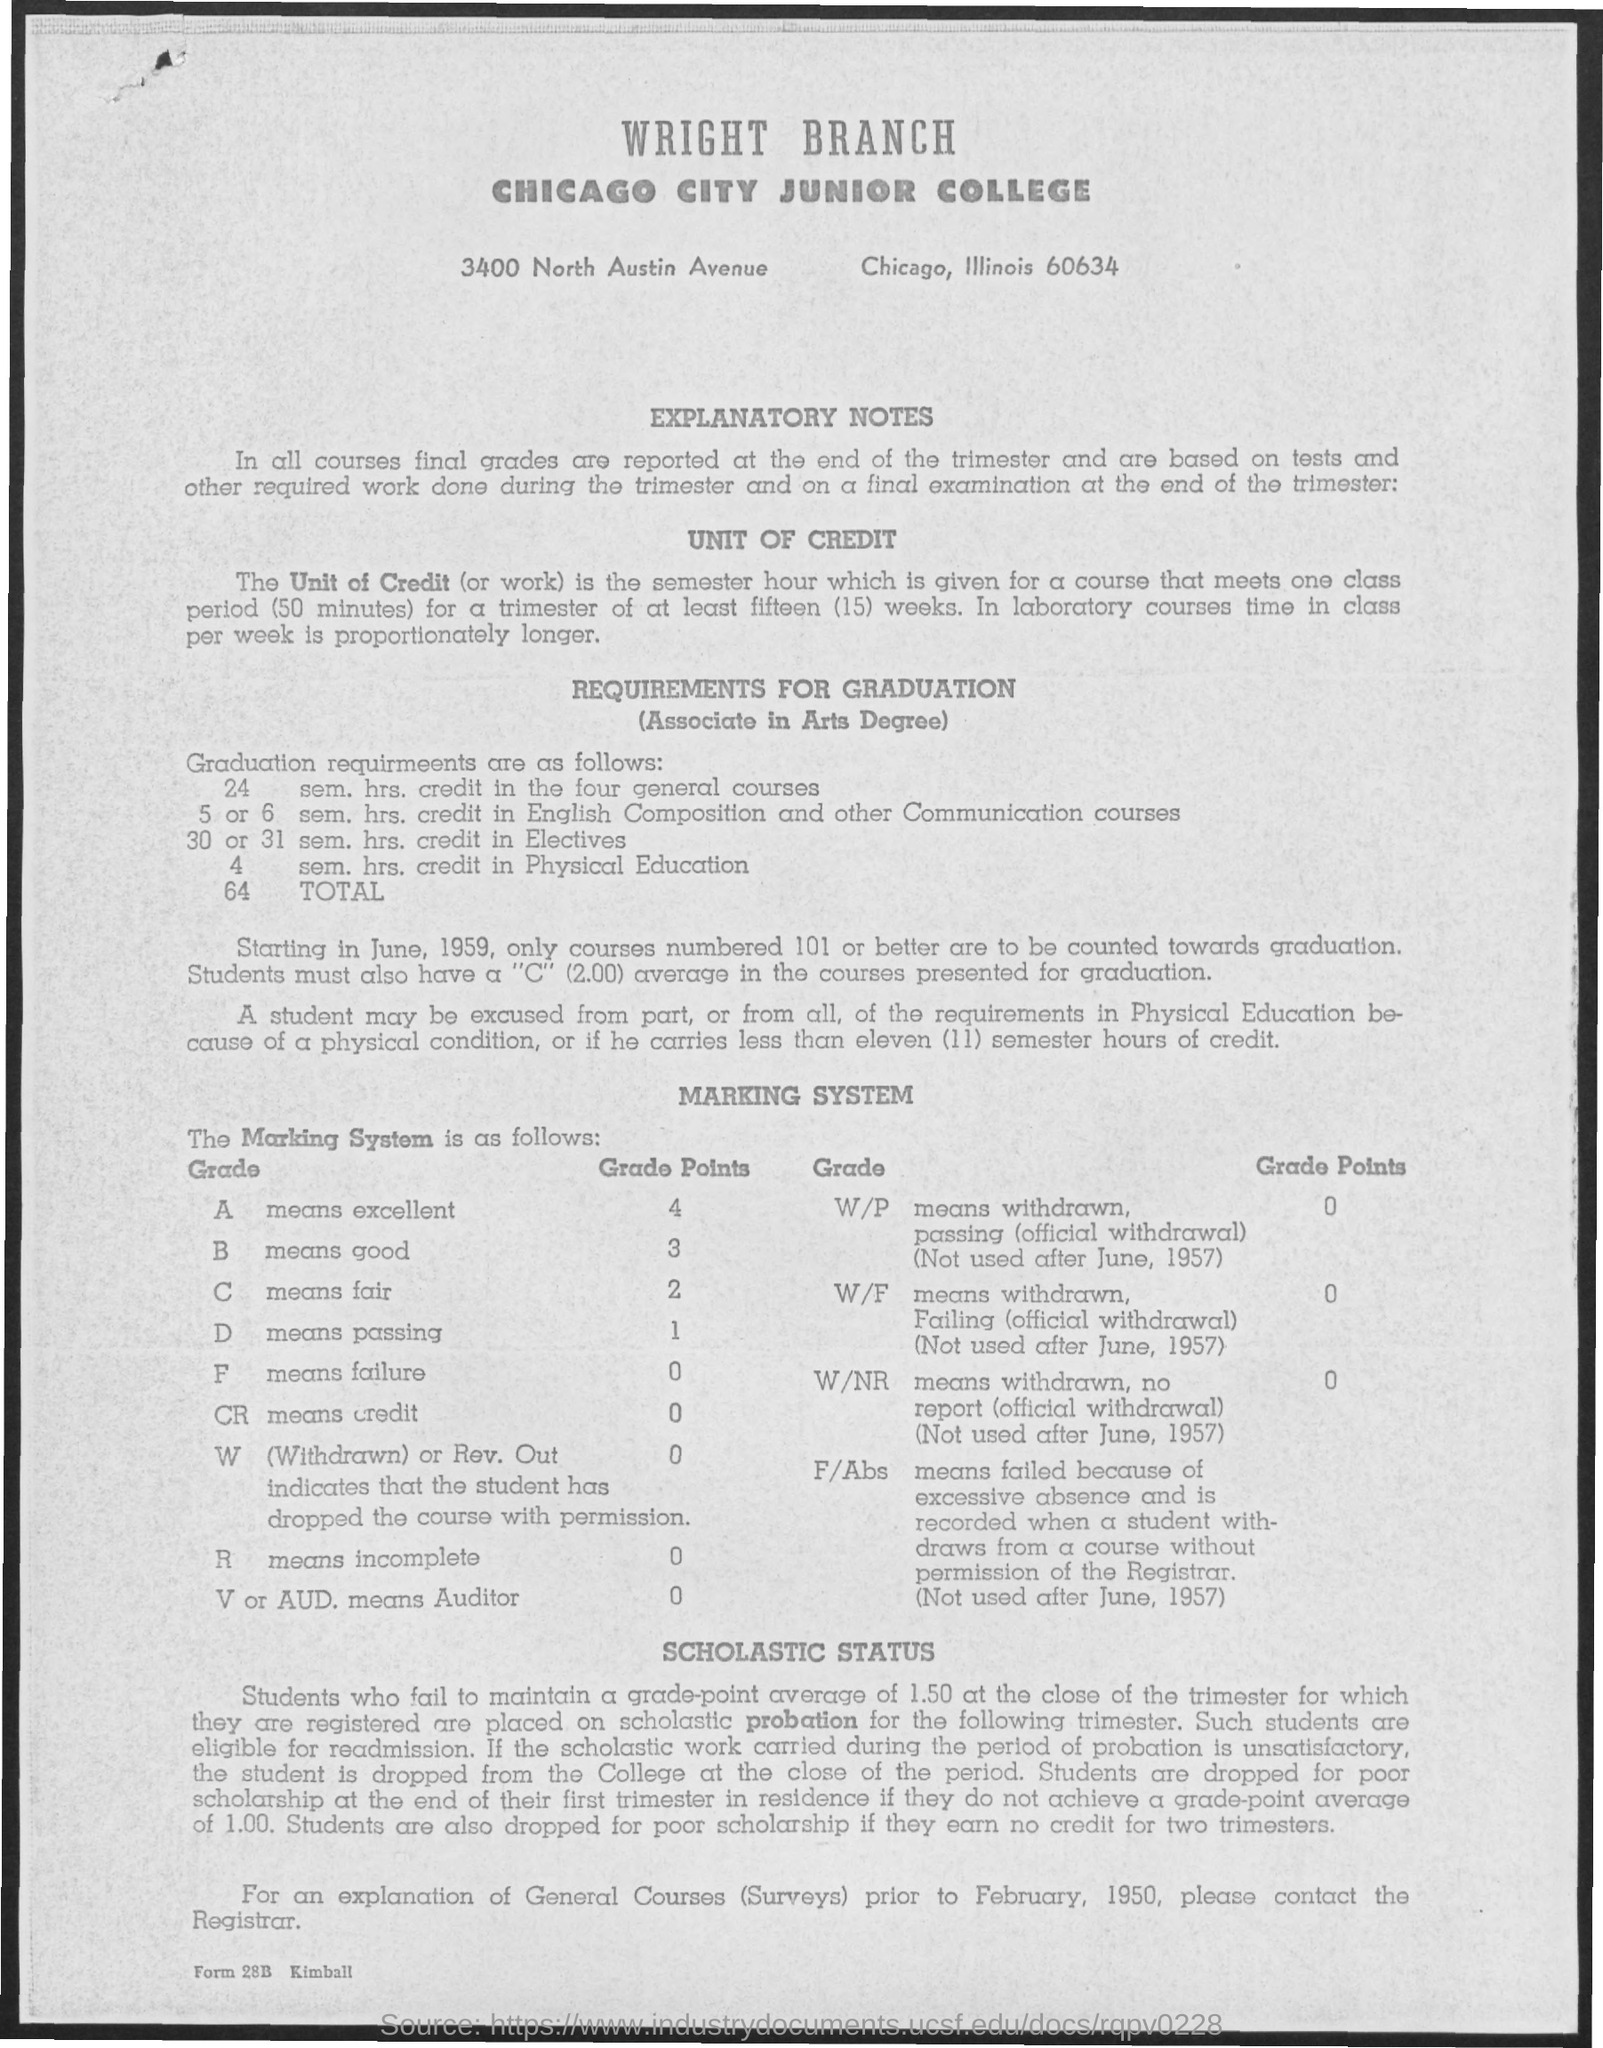Outline some significant characteristics in this image. The second title in the document is "Chicago City Junior College. The grade point for excellence is 4. The grade point for 'Good' is 3. The grade point for failure is 0 and ranges from 0 to (for example) 4.0. The grade point for 'Fair' is 2. 